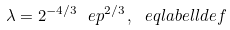Convert formula to latex. <formula><loc_0><loc_0><loc_500><loc_500>\lambda = 2 ^ { - 4 / 3 } \ e p ^ { 2 / 3 } \, , \ e q l a b e l { l d e f }</formula> 